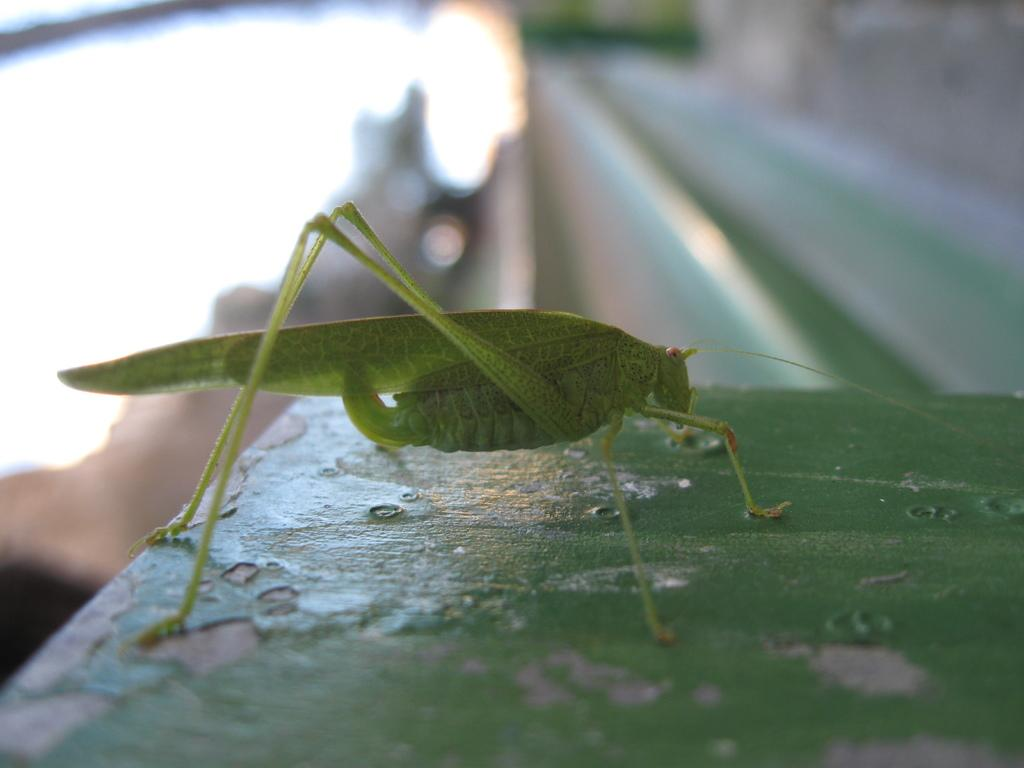What is the main subject of the picture? The main subject of the picture is a grasshopper. Can you describe the background of the image? The background of the image is blurry. What type of coat is the grasshopper wearing in the image? There is no coat present on the grasshopper in the image. How many sponges can be seen in the image? There are no sponges present in the image; it features a grasshopper and a blurry background. 